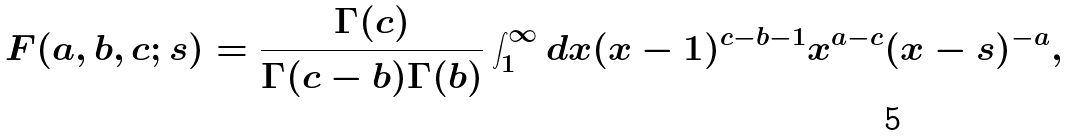Convert formula to latex. <formula><loc_0><loc_0><loc_500><loc_500>F ( a , b , c ; s ) = \frac { \Gamma ( c ) } { \Gamma ( c - b ) \Gamma ( b ) } \int _ { 1 } ^ { \infty } d x ( x - 1 ) ^ { c - b - 1 } x ^ { a - c } ( x - s ) ^ { - a } ,</formula> 